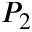Convert formula to latex. <formula><loc_0><loc_0><loc_500><loc_500>P _ { 2 }</formula> 